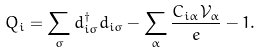<formula> <loc_0><loc_0><loc_500><loc_500>Q _ { i } = \sum _ { \sigma } d _ { i \sigma } ^ { \dagger } d _ { i \sigma } - \sum _ { \alpha } \frac { C _ { i \alpha } \mathcal { V } _ { \alpha } } { e } - 1 .</formula> 